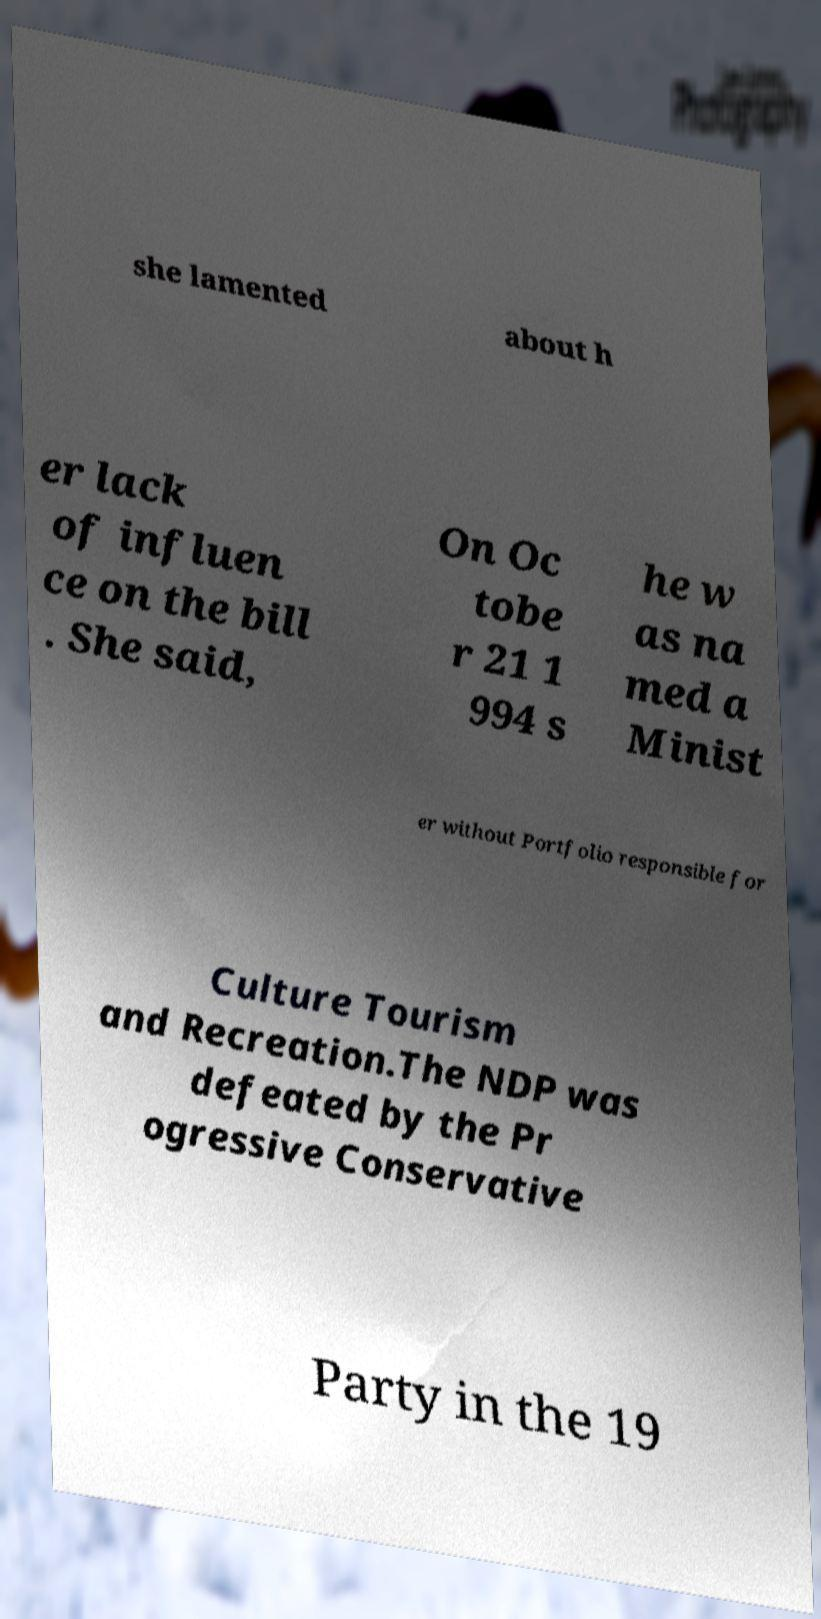Please read and relay the text visible in this image. What does it say? she lamented about h er lack of influen ce on the bill . She said, On Oc tobe r 21 1 994 s he w as na med a Minist er without Portfolio responsible for Culture Tourism and Recreation.The NDP was defeated by the Pr ogressive Conservative Party in the 19 